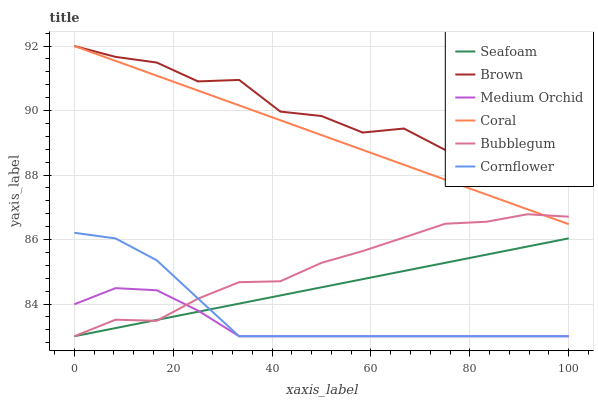Does Medium Orchid have the minimum area under the curve?
Answer yes or no. Yes. Does Brown have the maximum area under the curve?
Answer yes or no. Yes. Does Cornflower have the minimum area under the curve?
Answer yes or no. No. Does Cornflower have the maximum area under the curve?
Answer yes or no. No. Is Coral the smoothest?
Answer yes or no. Yes. Is Brown the roughest?
Answer yes or no. Yes. Is Cornflower the smoothest?
Answer yes or no. No. Is Cornflower the roughest?
Answer yes or no. No. Does Coral have the lowest value?
Answer yes or no. No. Does Coral have the highest value?
Answer yes or no. Yes. Does Cornflower have the highest value?
Answer yes or no. No. Is Cornflower less than Coral?
Answer yes or no. Yes. Is Brown greater than Seafoam?
Answer yes or no. Yes. Does Cornflower intersect Coral?
Answer yes or no. No. 